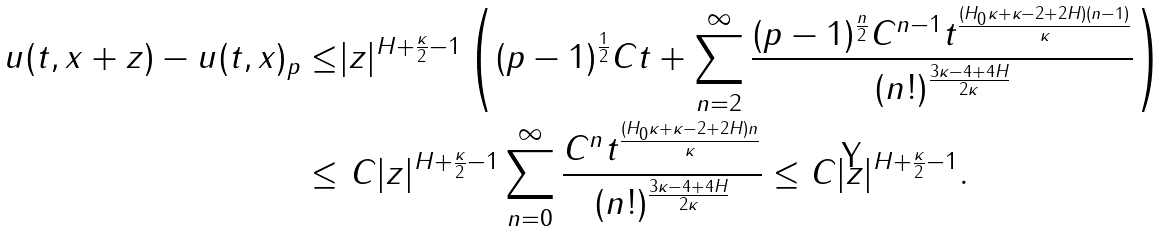<formula> <loc_0><loc_0><loc_500><loc_500>\| u ( t , x + z ) - u ( t , x ) \| _ { p } \leq & | z | ^ { H + \frac { \kappa } { 2 } - 1 } \left ( ( p - 1 ) ^ { \frac { 1 } { 2 } } C t + \sum _ { n = 2 } ^ { \infty } \frac { ( p - 1 ) ^ { \frac { n } { 2 } } C ^ { n - 1 } t ^ { \frac { ( H _ { 0 } \kappa + \kappa - 2 + 2 H ) ( n - 1 ) } { \kappa } } } { ( n ! ) ^ { \frac { 3 \kappa - 4 + 4 H } { 2 \kappa } } } \right ) \\ \leq & \ C | z | ^ { H + \frac { \kappa } { 2 } - 1 } \sum _ { n = 0 } ^ { \infty } \frac { C ^ { n } t ^ { \frac { ( H _ { 0 } \kappa + \kappa - 2 + 2 H ) n } { \kappa } } } { ( n ! ) ^ { \frac { 3 \kappa - 4 + 4 H } { 2 \kappa } } } \leq C | z | ^ { H + \frac { \kappa } { 2 } - 1 } .</formula> 